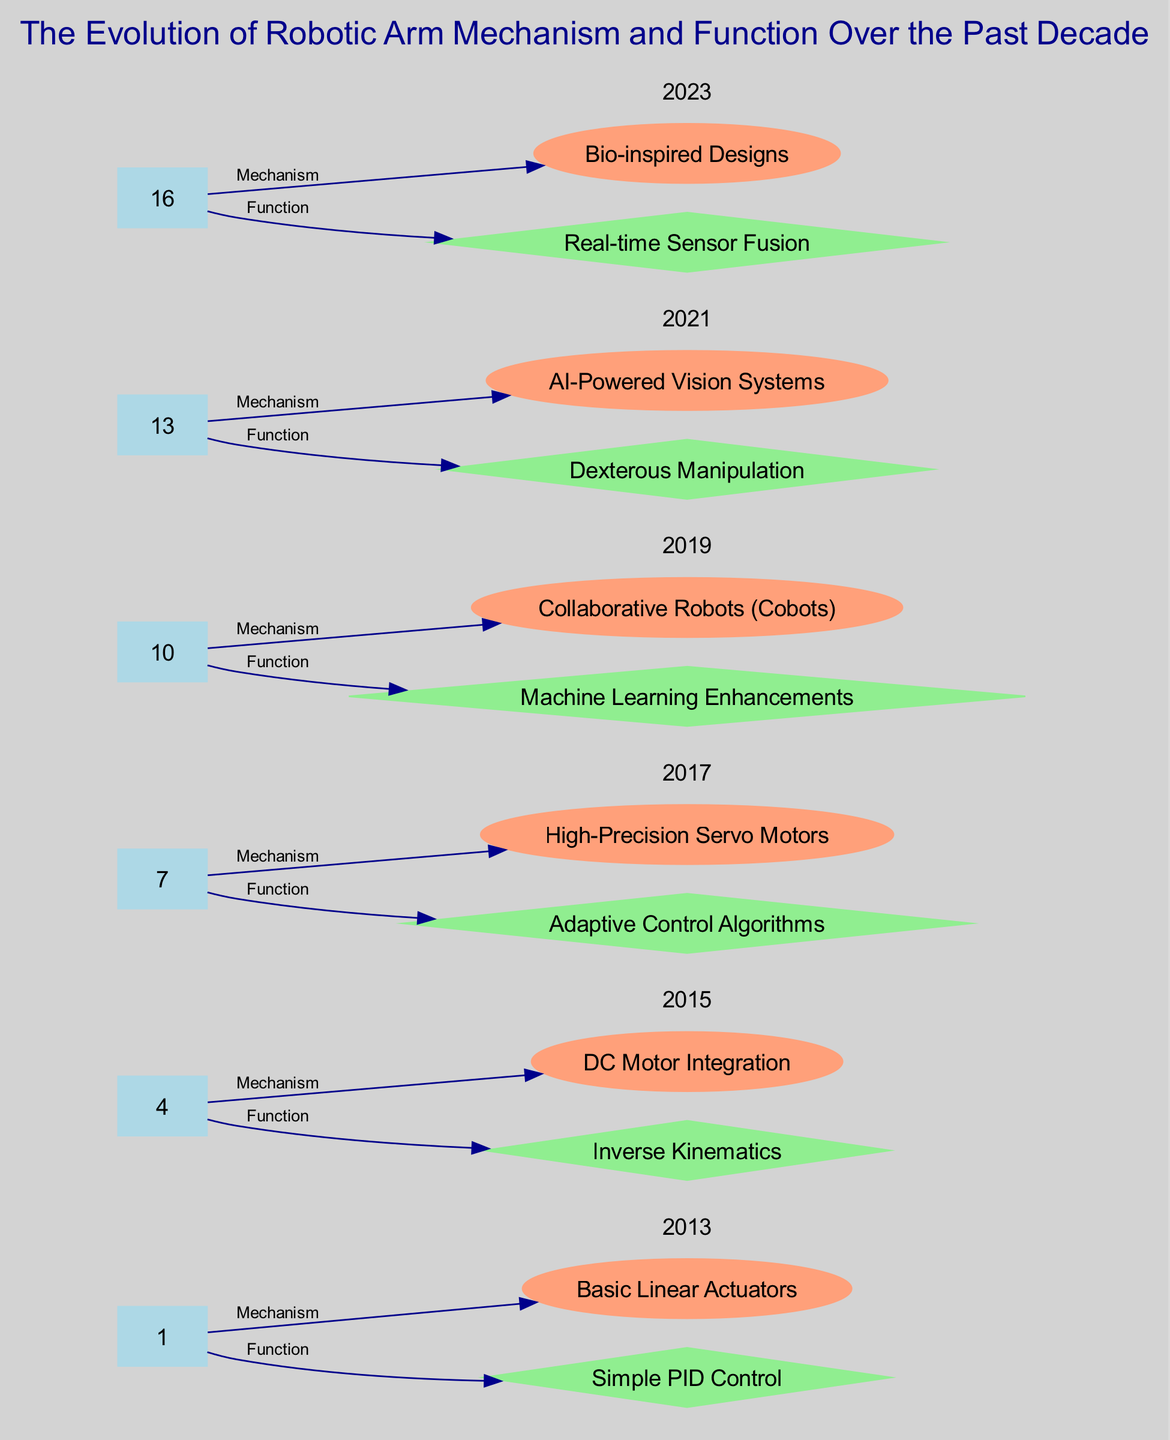What year is associated with Basic Linear Actuators? By analyzing the diagram, we can see that the node labeled "Basic Linear Actuators" connects to the node "2013." This indicates that 2013 is the year associated with this mechanism.
Answer: 2013 How many nodes represent years in the diagram? Upon examining the nodes, we identify that there are six nodes specifically labeled with years: 2013, 2015, 2017, 2019, 2021, and 2023. Therefore, the count of these year nodes is six.
Answer: 6 Which mechanism was introduced in 2019? Following the diagram flow, we see that under the node "2019," the mechanism labeled "Collaborative Robots (Cobots)" is linked. Thus, this is the mechanism introduced in that year.
Answer: Collaborative Robots (Cobots) What function is linked to the year 2021? Looking at the connections from the node "2021," we find two functions. The function "AI-Powered Vision Systems" points from this year. Therefore, the function linked to 2021 is identified as such.
Answer: AI-Powered Vision Systems What is the relationship between High-Precision Servo Motors and Inverse Kinematics? In checking the edges of the diagram, we see that "High-Precision Servo Motors" connects to the year 2017, while "Inverse Kinematics" connects to 2015. There is no direct edge connecting these two nodes, which indicates their relationship is indirect and tied to different years.
Answer: No direct relationship What development combines AI and vision systems as of 2021? By inspecting the edge relationship from the "2021" node to the corresponding functions, we note that it is "AI-Powered Vision Systems" that combines AI functionality with vision systems. This combination is evident from the layout of the diagram.
Answer: AI-Powered Vision Systems Which mechanism introduced in 2017 supports Adaptive Control Algorithms? In the diagram, we can see that under the year 2017, "High-Precision Servo Motors" is listed, which connects to "Adaptive Control Algorithms." This indicates that the high-precision servo motors mechanism supports the adaptive control algorithms introduced in the same year.
Answer: High-Precision Servo Motors How does Bio-inspired Designs relate to Real-time Sensor Fusion? By following the edges from the node "2023," we observe that "Bio-inspired Designs" is mechanistic while "Real-time Sensor Fusion" is functional, indicating that on this path, Bio-inspired Designs is connected to Real-time Sensor Fusion, thus showing the relationship through mechanism and functionality.
Answer: Mechanism to function relationship What is a common feature shared by mechanisms from 2015 and 2017? Comparing both years, in 2015 the mechanism involves "DC Motor Integration" and in 2017, the mechanism involves "High-Precision Servo Motors." The common feature is their focus on enhancing motor capabilities for improved robotic performance.
Answer: Motor enhancement 